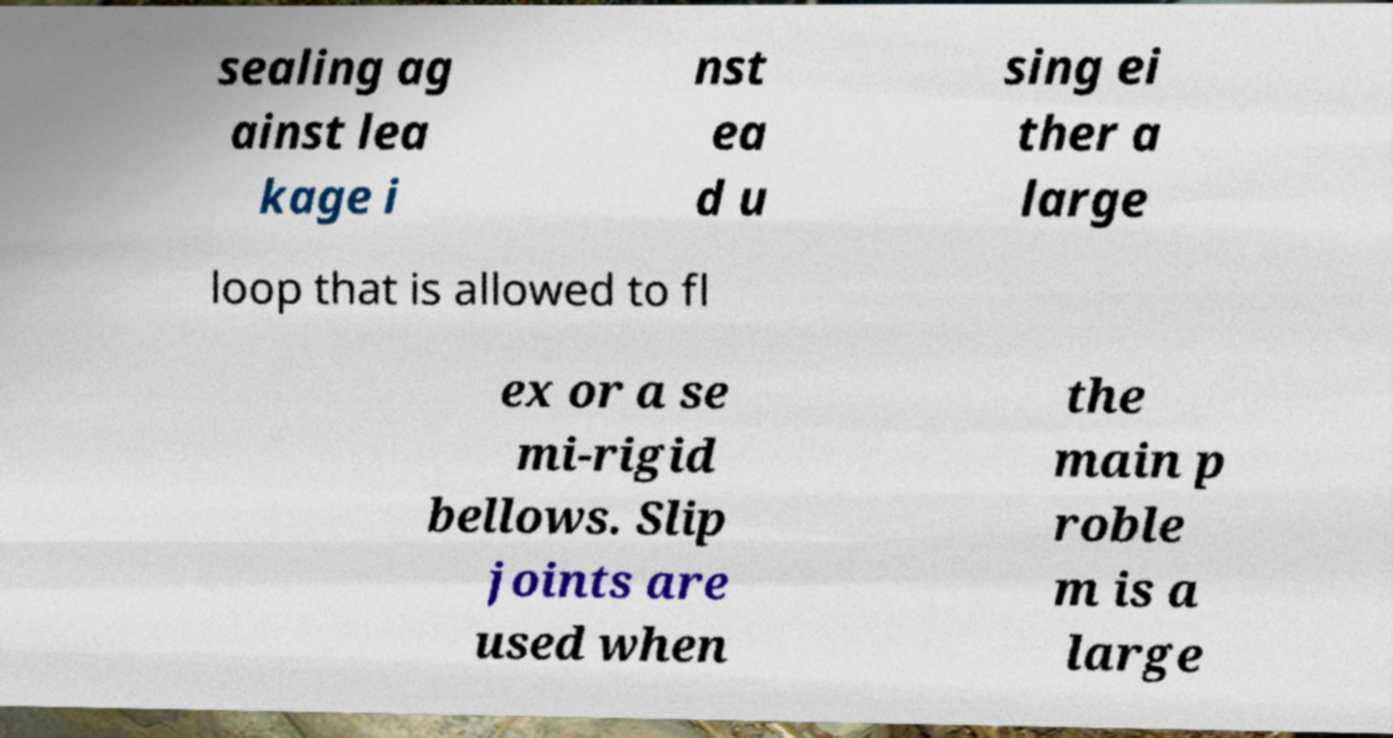I need the written content from this picture converted into text. Can you do that? sealing ag ainst lea kage i nst ea d u sing ei ther a large loop that is allowed to fl ex or a se mi-rigid bellows. Slip joints are used when the main p roble m is a large 